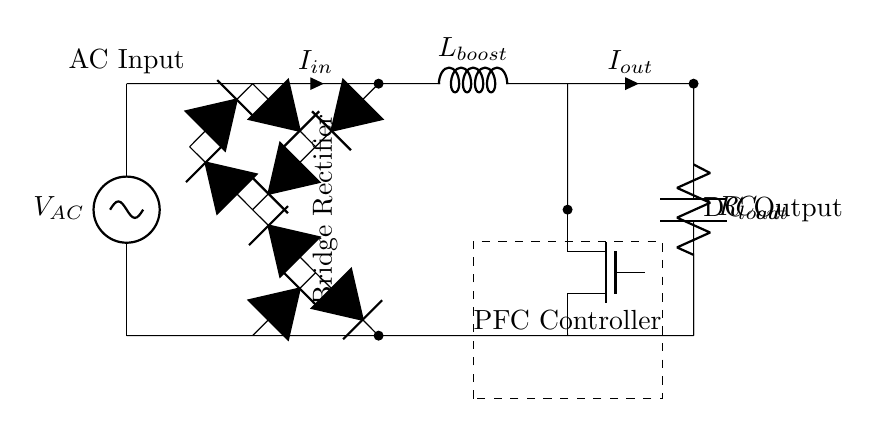What type of circuit is this? This circuit is a power factor correction circuit. The presence of the inductor and capacitor indicates that it is designed to improve the power factor for more efficient energy usage.
Answer: power factor correction circuit What does the inductor represent in this circuit? The inductor, labeled as L boost, serves to boost the voltage and assist in correcting the power factor by storing energy in a magnetic field.
Answer: L boost What is the function of the MOSFET in this circuit? The MOSFET, labeled as Q1, is used for switching and controlling the current flow in the circuit, which is essential for the operation of the power factor correction controller.
Answer: switching What is the purpose of the bridge rectifier in this circuit? The bridge rectifier converts alternating current (AC) to direct current (DC), allowing the power factor correction circuit to function properly by utilizing DC voltage.
Answer: convert AC to DC Which component is responsible for current regulation? The PFC controller, seen in the dashed rectangle, regulates the current through the circuit, ensuring that the output remains stable and meets the required specifications.
Answer: PFC controller What is the electrical symbol for the load in this circuit? The load is represented by the resistor symbol labeled as R load, which consumes the power supplied by the circuit.
Answer: R load What type of current flows through the output? The output current is direct current (DC) as a result of the bridge rectifier's conversion, which is indicated by the label DC output.
Answer: DC 